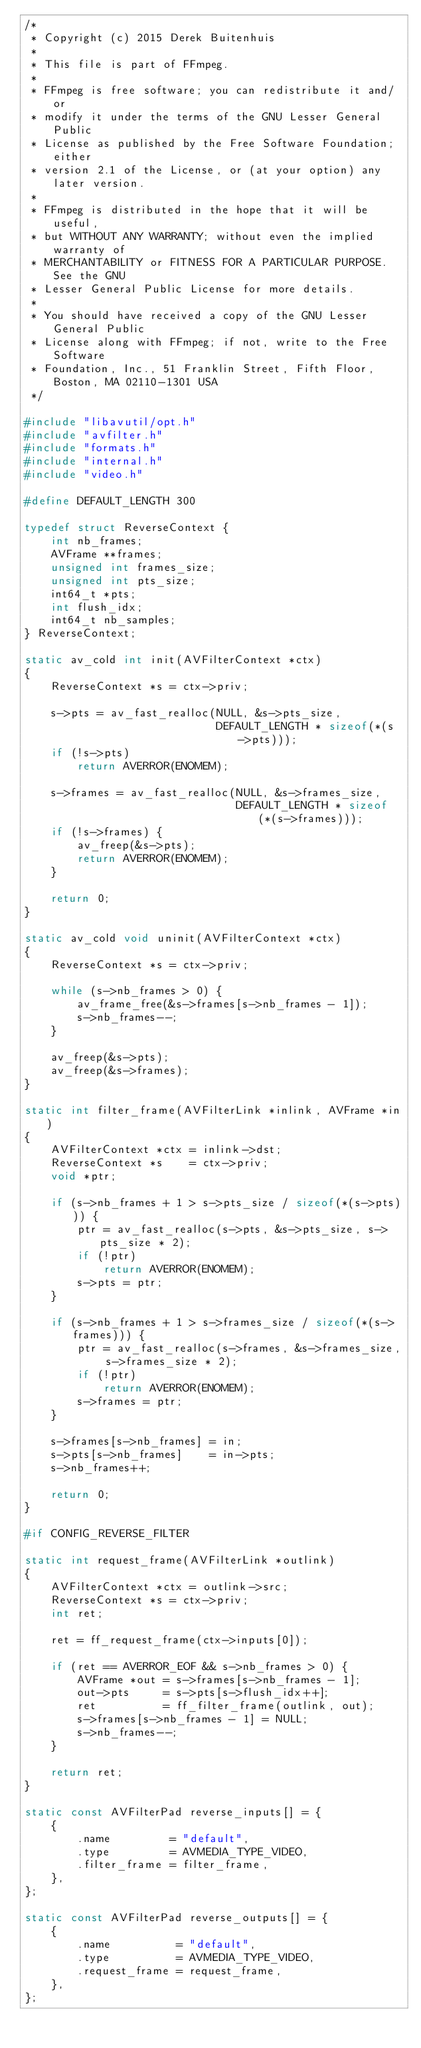<code> <loc_0><loc_0><loc_500><loc_500><_C_>/*
 * Copyright (c) 2015 Derek Buitenhuis
 *
 * This file is part of FFmpeg.
 *
 * FFmpeg is free software; you can redistribute it and/or
 * modify it under the terms of the GNU Lesser General Public
 * License as published by the Free Software Foundation; either
 * version 2.1 of the License, or (at your option) any later version.
 *
 * FFmpeg is distributed in the hope that it will be useful,
 * but WITHOUT ANY WARRANTY; without even the implied warranty of
 * MERCHANTABILITY or FITNESS FOR A PARTICULAR PURPOSE.  See the GNU
 * Lesser General Public License for more details.
 *
 * You should have received a copy of the GNU Lesser General Public
 * License along with FFmpeg; if not, write to the Free Software
 * Foundation, Inc., 51 Franklin Street, Fifth Floor, Boston, MA 02110-1301 USA
 */

#include "libavutil/opt.h"
#include "avfilter.h"
#include "formats.h"
#include "internal.h"
#include "video.h"

#define DEFAULT_LENGTH 300

typedef struct ReverseContext {
    int nb_frames;
    AVFrame **frames;
    unsigned int frames_size;
    unsigned int pts_size;
    int64_t *pts;
    int flush_idx;
    int64_t nb_samples;
} ReverseContext;

static av_cold int init(AVFilterContext *ctx)
{
    ReverseContext *s = ctx->priv;

    s->pts = av_fast_realloc(NULL, &s->pts_size,
                             DEFAULT_LENGTH * sizeof(*(s->pts)));
    if (!s->pts)
        return AVERROR(ENOMEM);

    s->frames = av_fast_realloc(NULL, &s->frames_size,
                                DEFAULT_LENGTH * sizeof(*(s->frames)));
    if (!s->frames) {
        av_freep(&s->pts);
        return AVERROR(ENOMEM);
    }

    return 0;
}

static av_cold void uninit(AVFilterContext *ctx)
{
    ReverseContext *s = ctx->priv;

    while (s->nb_frames > 0) {
        av_frame_free(&s->frames[s->nb_frames - 1]);
        s->nb_frames--;
    }

    av_freep(&s->pts);
    av_freep(&s->frames);
}

static int filter_frame(AVFilterLink *inlink, AVFrame *in)
{
    AVFilterContext *ctx = inlink->dst;
    ReverseContext *s    = ctx->priv;
    void *ptr;

    if (s->nb_frames + 1 > s->pts_size / sizeof(*(s->pts))) {
        ptr = av_fast_realloc(s->pts, &s->pts_size, s->pts_size * 2);
        if (!ptr)
            return AVERROR(ENOMEM);
        s->pts = ptr;
    }

    if (s->nb_frames + 1 > s->frames_size / sizeof(*(s->frames))) {
        ptr = av_fast_realloc(s->frames, &s->frames_size, s->frames_size * 2);
        if (!ptr)
            return AVERROR(ENOMEM);
        s->frames = ptr;
    }

    s->frames[s->nb_frames] = in;
    s->pts[s->nb_frames]    = in->pts;
    s->nb_frames++;

    return 0;
}

#if CONFIG_REVERSE_FILTER

static int request_frame(AVFilterLink *outlink)
{
    AVFilterContext *ctx = outlink->src;
    ReverseContext *s = ctx->priv;
    int ret;

    ret = ff_request_frame(ctx->inputs[0]);

    if (ret == AVERROR_EOF && s->nb_frames > 0) {
        AVFrame *out = s->frames[s->nb_frames - 1];
        out->pts     = s->pts[s->flush_idx++];
        ret          = ff_filter_frame(outlink, out);
        s->frames[s->nb_frames - 1] = NULL;
        s->nb_frames--;
    }

    return ret;
}

static const AVFilterPad reverse_inputs[] = {
    {
        .name         = "default",
        .type         = AVMEDIA_TYPE_VIDEO,
        .filter_frame = filter_frame,
    },
};

static const AVFilterPad reverse_outputs[] = {
    {
        .name          = "default",
        .type          = AVMEDIA_TYPE_VIDEO,
        .request_frame = request_frame,
    },
};
</code> 